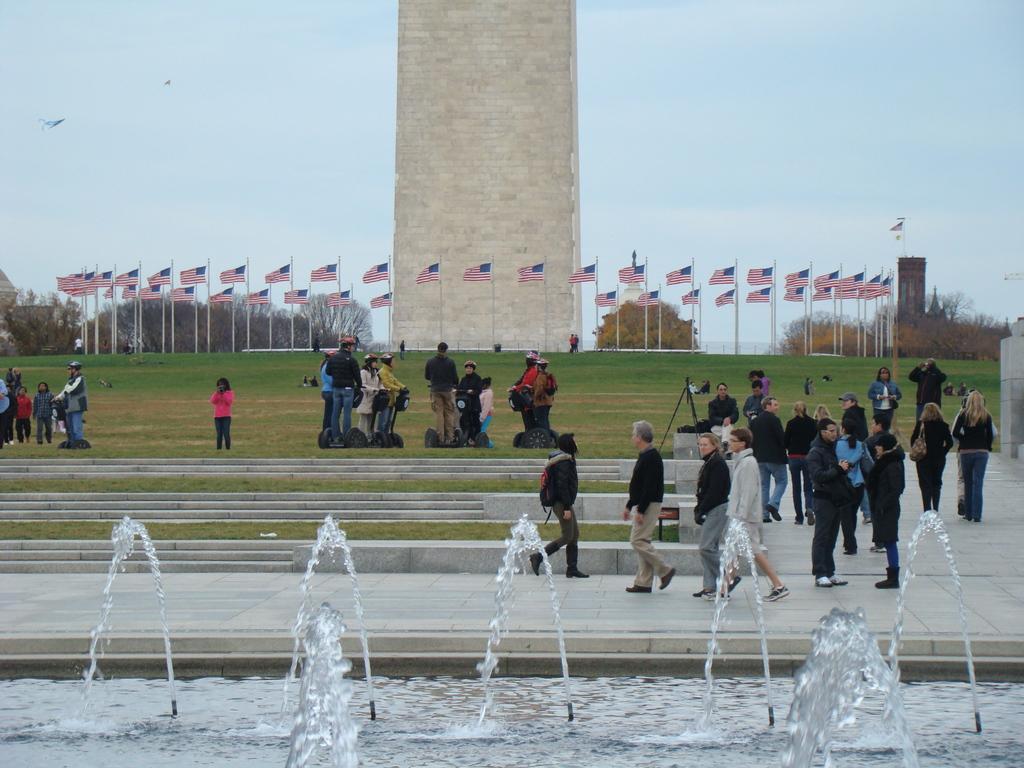Please provide a concise description of this image. This image consists of many people standing and walking. At the bottom, there is a fountains. In the front, we can see a big wall along with flags and trees. At the bottom, there is grass on the ground. In the front, there are steps. At the top, there is sky. 